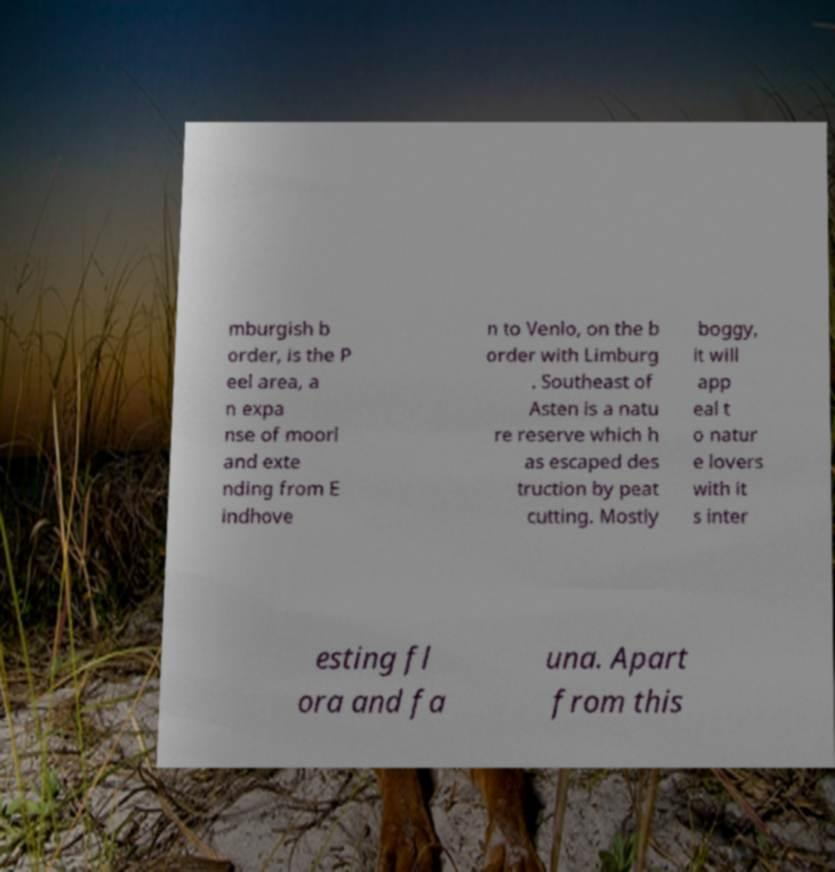Could you extract and type out the text from this image? mburgish b order, is the P eel area, a n expa nse of moorl and exte nding from E indhove n to Venlo, on the b order with Limburg . Southeast of Asten is a natu re reserve which h as escaped des truction by peat cutting. Mostly boggy, it will app eal t o natur e lovers with it s inter esting fl ora and fa una. Apart from this 